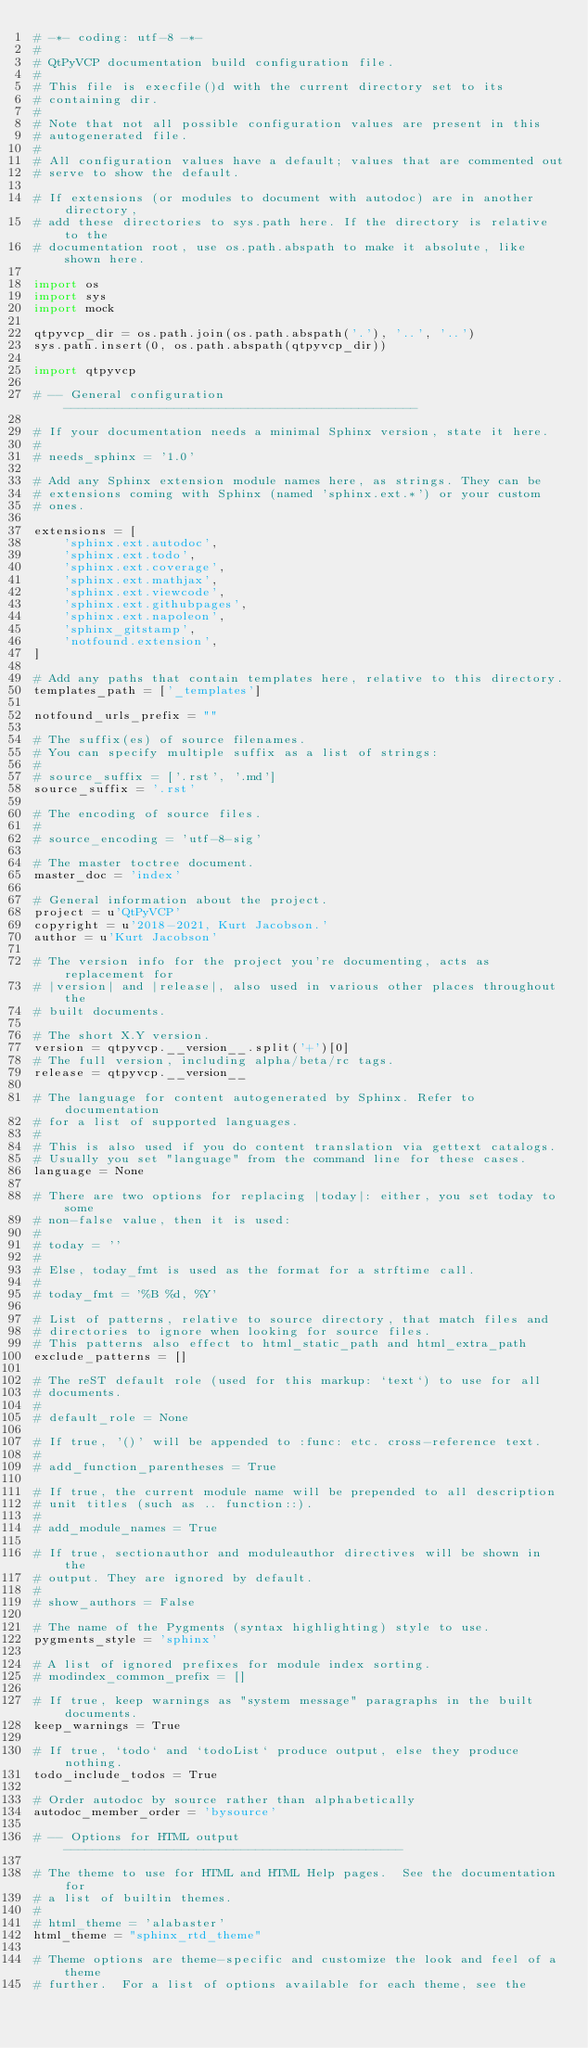Convert code to text. <code><loc_0><loc_0><loc_500><loc_500><_Python_># -*- coding: utf-8 -*-
#
# QtPyVCP documentation build configuration file.
#
# This file is execfile()d with the current directory set to its
# containing dir.
#
# Note that not all possible configuration values are present in this
# autogenerated file.
#
# All configuration values have a default; values that are commented out
# serve to show the default.

# If extensions (or modules to document with autodoc) are in another directory,
# add these directories to sys.path here. If the directory is relative to the
# documentation root, use os.path.abspath to make it absolute, like shown here.

import os
import sys
import mock

qtpyvcp_dir = os.path.join(os.path.abspath('.'), '..', '..')
sys.path.insert(0, os.path.abspath(qtpyvcp_dir))

import qtpyvcp

# -- General configuration ------------------------------------------------

# If your documentation needs a minimal Sphinx version, state it here.
#
# needs_sphinx = '1.0'

# Add any Sphinx extension module names here, as strings. They can be
# extensions coming with Sphinx (named 'sphinx.ext.*') or your custom
# ones.

extensions = [
    'sphinx.ext.autodoc',
    'sphinx.ext.todo',
    'sphinx.ext.coverage',
    'sphinx.ext.mathjax',
    'sphinx.ext.viewcode',
    'sphinx.ext.githubpages',
    'sphinx.ext.napoleon',
    'sphinx_gitstamp',
    'notfound.extension',
]

# Add any paths that contain templates here, relative to this directory.
templates_path = ['_templates']

notfound_urls_prefix = ""

# The suffix(es) of source filenames.
# You can specify multiple suffix as a list of strings:
#
# source_suffix = ['.rst', '.md']
source_suffix = '.rst'

# The encoding of source files.
#
# source_encoding = 'utf-8-sig'

# The master toctree document.
master_doc = 'index'

# General information about the project.
project = u'QtPyVCP'
copyright = u'2018-2021, Kurt Jacobson.'
author = u'Kurt Jacobson'

# The version info for the project you're documenting, acts as replacement for
# |version| and |release|, also used in various other places throughout the
# built documents.

# The short X.Y version.
version = qtpyvcp.__version__.split('+')[0]
# The full version, including alpha/beta/rc tags.
release = qtpyvcp.__version__

# The language for content autogenerated by Sphinx. Refer to documentation
# for a list of supported languages.
#
# This is also used if you do content translation via gettext catalogs.
# Usually you set "language" from the command line for these cases.
language = None

# There are two options for replacing |today|: either, you set today to some
# non-false value, then it is used:
#
# today = ''
#
# Else, today_fmt is used as the format for a strftime call.
#
# today_fmt = '%B %d, %Y'

# List of patterns, relative to source directory, that match files and
# directories to ignore when looking for source files.
# This patterns also effect to html_static_path and html_extra_path
exclude_patterns = []

# The reST default role (used for this markup: `text`) to use for all
# documents.
#
# default_role = None

# If true, '()' will be appended to :func: etc. cross-reference text.
#
# add_function_parentheses = True

# If true, the current module name will be prepended to all description
# unit titles (such as .. function::).
#
# add_module_names = True

# If true, sectionauthor and moduleauthor directives will be shown in the
# output. They are ignored by default.
#
# show_authors = False

# The name of the Pygments (syntax highlighting) style to use.
pygments_style = 'sphinx'

# A list of ignored prefixes for module index sorting.
# modindex_common_prefix = []

# If true, keep warnings as "system message" paragraphs in the built documents.
keep_warnings = True

# If true, `todo` and `todoList` produce output, else they produce nothing.
todo_include_todos = True

# Order autodoc by source rather than alphabetically
autodoc_member_order = 'bysource'

# -- Options for HTML output ----------------------------------------------

# The theme to use for HTML and HTML Help pages.  See the documentation for
# a list of builtin themes.
#
# html_theme = 'alabaster'
html_theme = "sphinx_rtd_theme"

# Theme options are theme-specific and customize the look and feel of a theme
# further.  For a list of options available for each theme, see the</code> 